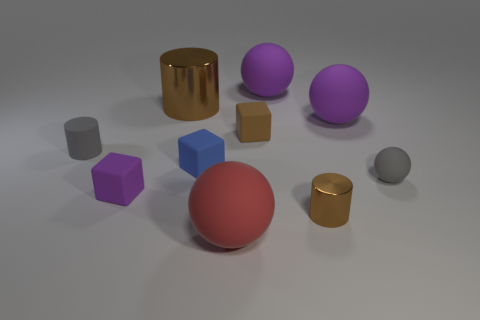Subtract all brown matte blocks. How many blocks are left? 2 Subtract all brown balls. How many brown cylinders are left? 2 Subtract 2 balls. How many balls are left? 2 Subtract all purple blocks. How many blocks are left? 2 Subtract all cylinders. How many objects are left? 7 Add 8 metallic cylinders. How many metallic cylinders exist? 10 Subtract 0 cyan cylinders. How many objects are left? 10 Subtract all red blocks. Subtract all gray cylinders. How many blocks are left? 3 Subtract all tiny brown matte cubes. Subtract all big purple rubber objects. How many objects are left? 7 Add 4 rubber blocks. How many rubber blocks are left? 7 